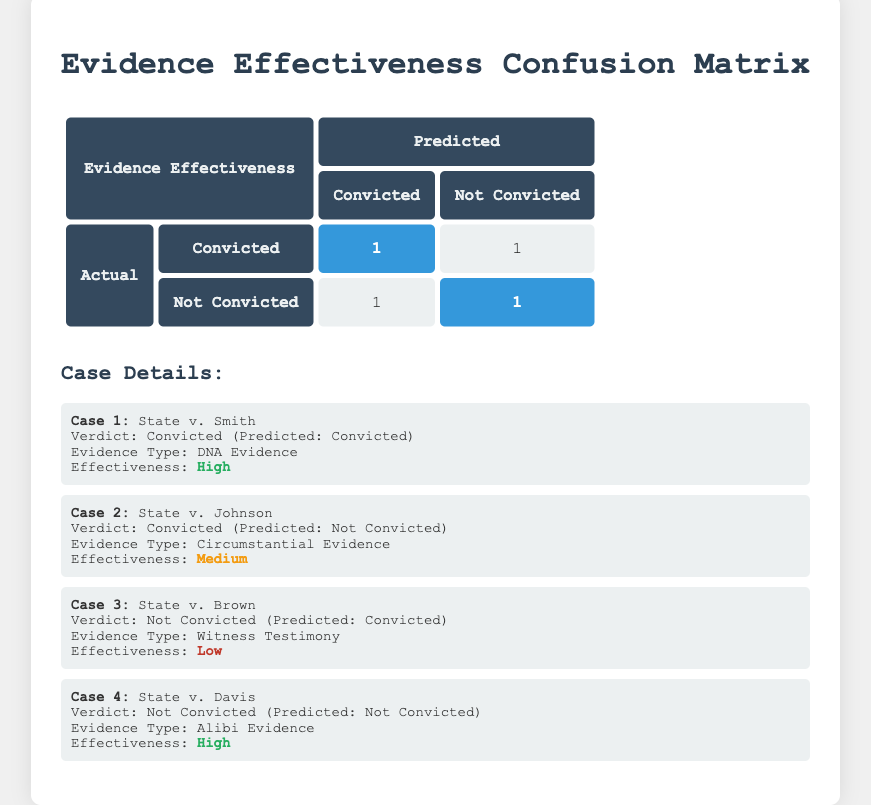What is the effectiveness of evidence presented in State v. Smith? The evidence type presented in State v. Smith is DNA Evidence, and the effectiveness rating for this evidence is classified as High.
Answer: High How many cases predicted a conviction incorrectly? Two cases predicted a conviction incorrectly. This includes State v. Johnson, which predicted Not Convicted but the actual verdict was Convicted, and State v. Brown, which predicted Convicted but the actual verdict was Not Convicted.
Answer: 2 Is there any case where the effectiveness of the evidence is rated as Low? Yes, there is a case where the effectiveness of the evidence is rated as Low. In State v. Brown, the evidence type was Witness Testimony, and its effectiveness was rated Low.
Answer: Yes How many cases involved High effectiveness evidence? There are two cases involving High effectiveness evidence. These are State v. Smith (DNA Evidence) and State v. Davis (Alibi Evidence).
Answer: 2 What is the overall effectiveness correlation between actual convictions and predictions? The data suggests that all cases where the prediction was Convicted were true for State v. Smith, reflecting high effectiveness with DNA evidence. However, the predictions were inaccurate in cases like State v. Johnson and State v. Brown, where the effectiveness did not align with a conviction. Thus, there is a mixed correlation, as effective evidence can lead to accurate predictions but not consistently.
Answer: Mixed correlation 